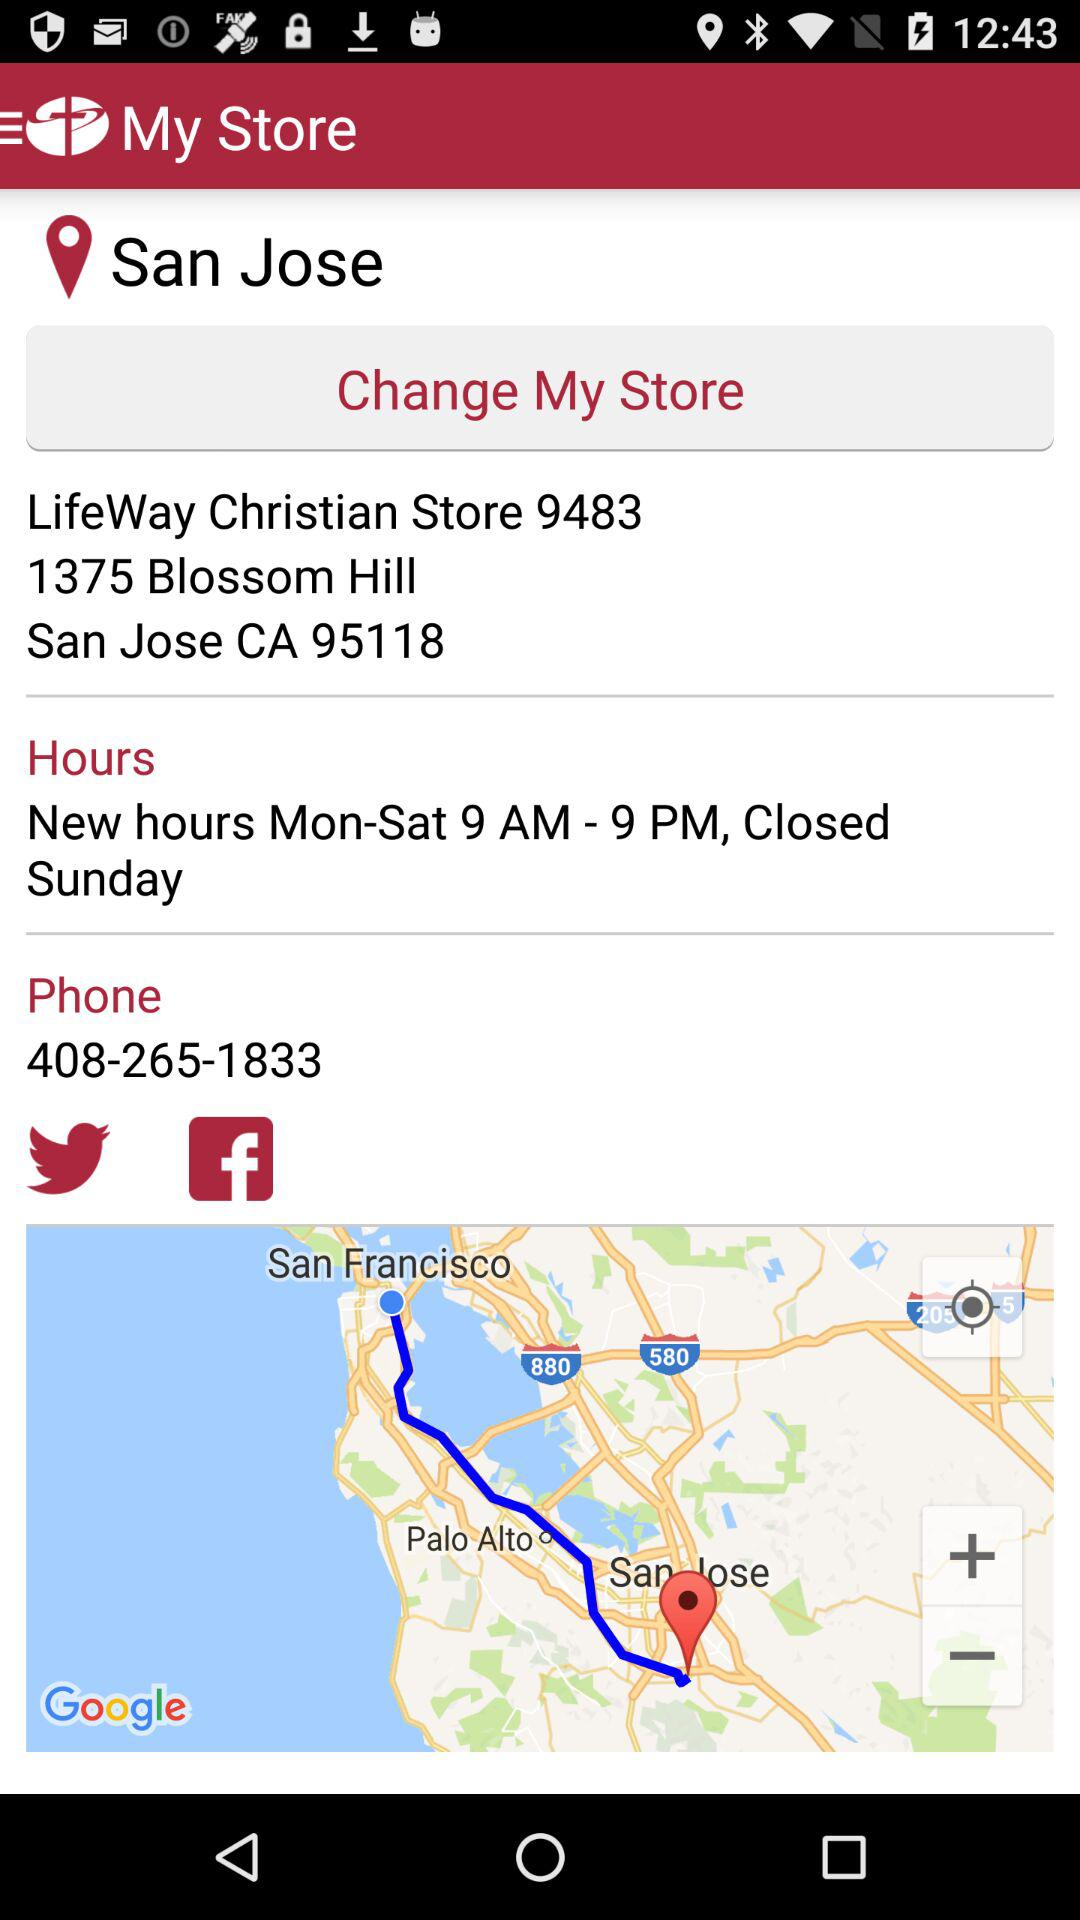What is the address of the store? The address is 1375 Blossom Hill, San Jose, CA 95118. 